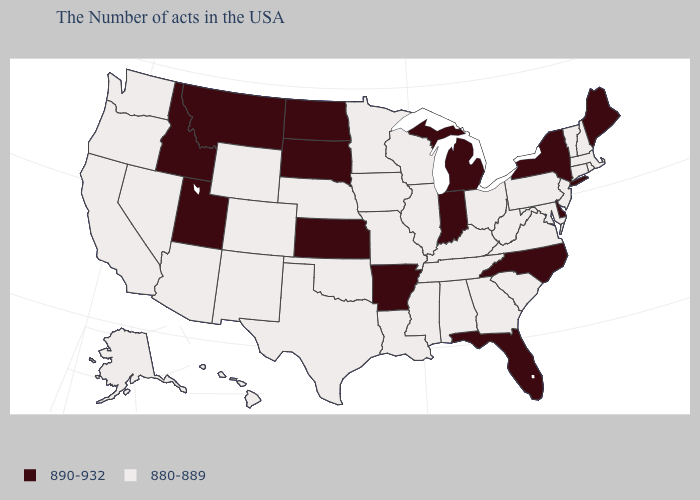What is the value of Alaska?
Give a very brief answer. 880-889. Which states have the lowest value in the USA?
Give a very brief answer. Massachusetts, Rhode Island, New Hampshire, Vermont, Connecticut, New Jersey, Maryland, Pennsylvania, Virginia, South Carolina, West Virginia, Ohio, Georgia, Kentucky, Alabama, Tennessee, Wisconsin, Illinois, Mississippi, Louisiana, Missouri, Minnesota, Iowa, Nebraska, Oklahoma, Texas, Wyoming, Colorado, New Mexico, Arizona, Nevada, California, Washington, Oregon, Alaska, Hawaii. Name the states that have a value in the range 890-932?
Short answer required. Maine, New York, Delaware, North Carolina, Florida, Michigan, Indiana, Arkansas, Kansas, South Dakota, North Dakota, Utah, Montana, Idaho. Is the legend a continuous bar?
Keep it brief. No. What is the value of Illinois?
Quick response, please. 880-889. What is the value of New Hampshire?
Quick response, please. 880-889. Which states have the highest value in the USA?
Keep it brief. Maine, New York, Delaware, North Carolina, Florida, Michigan, Indiana, Arkansas, Kansas, South Dakota, North Dakota, Utah, Montana, Idaho. Which states have the lowest value in the Northeast?
Answer briefly. Massachusetts, Rhode Island, New Hampshire, Vermont, Connecticut, New Jersey, Pennsylvania. What is the value of Georgia?
Quick response, please. 880-889. What is the value of New Hampshire?
Quick response, please. 880-889. Does South Dakota have the same value as Florida?
Quick response, please. Yes. Which states have the lowest value in the South?
Concise answer only. Maryland, Virginia, South Carolina, West Virginia, Georgia, Kentucky, Alabama, Tennessee, Mississippi, Louisiana, Oklahoma, Texas. What is the value of Montana?
Give a very brief answer. 890-932. Does California have the highest value in the USA?
Be succinct. No. 